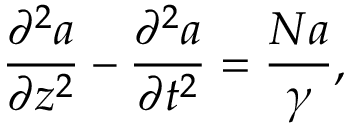<formula> <loc_0><loc_0><loc_500><loc_500>\frac { \partial ^ { 2 } a } { \partial z ^ { 2 } } - \frac { \partial ^ { 2 } a } { \partial t ^ { 2 } } = \frac { N a } { \gamma } ,</formula> 